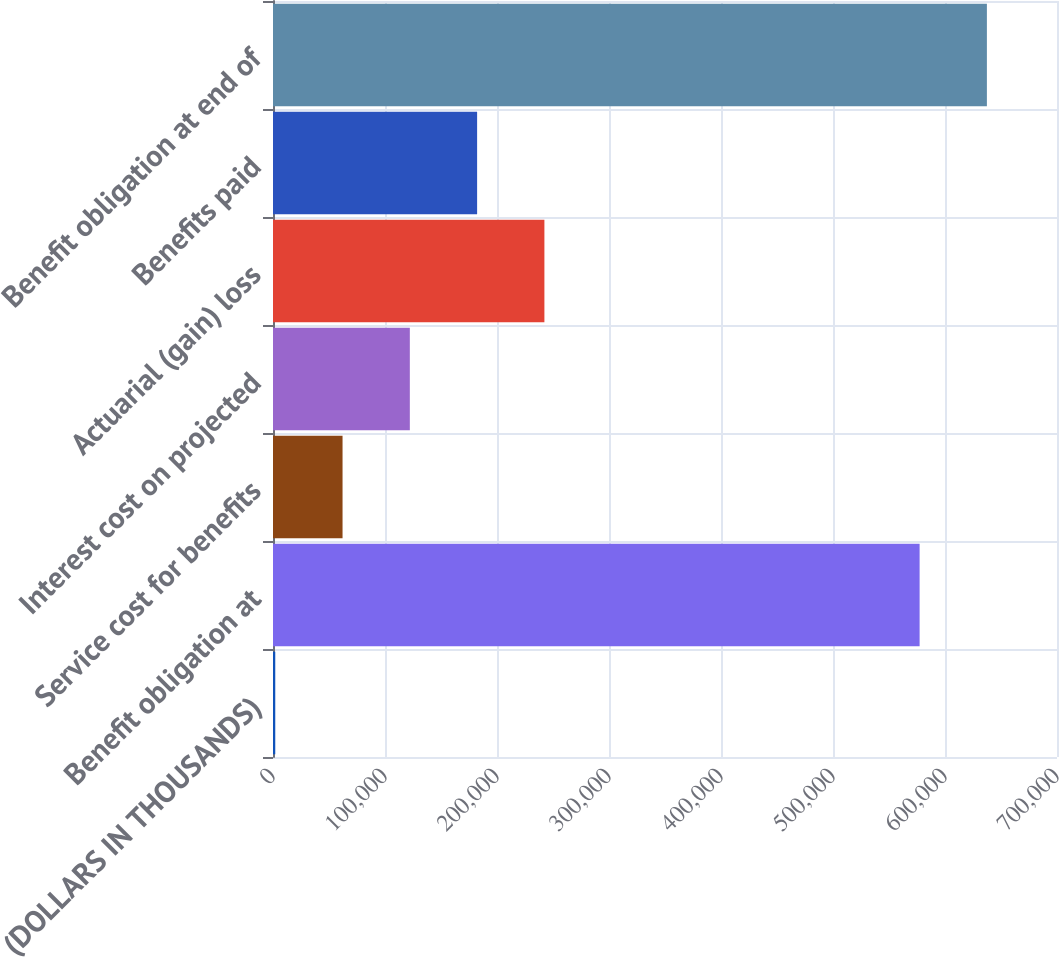Convert chart. <chart><loc_0><loc_0><loc_500><loc_500><bar_chart><fcel>(DOLLARS IN THOUSANDS)<fcel>Benefit obligation at<fcel>Service cost for benefits<fcel>Interest cost on projected<fcel>Actuarial (gain) loss<fcel>Benefits paid<fcel>Benefit obligation at end of<nl><fcel>2017<fcel>577332<fcel>62093.6<fcel>122170<fcel>242323<fcel>182247<fcel>637409<nl></chart> 